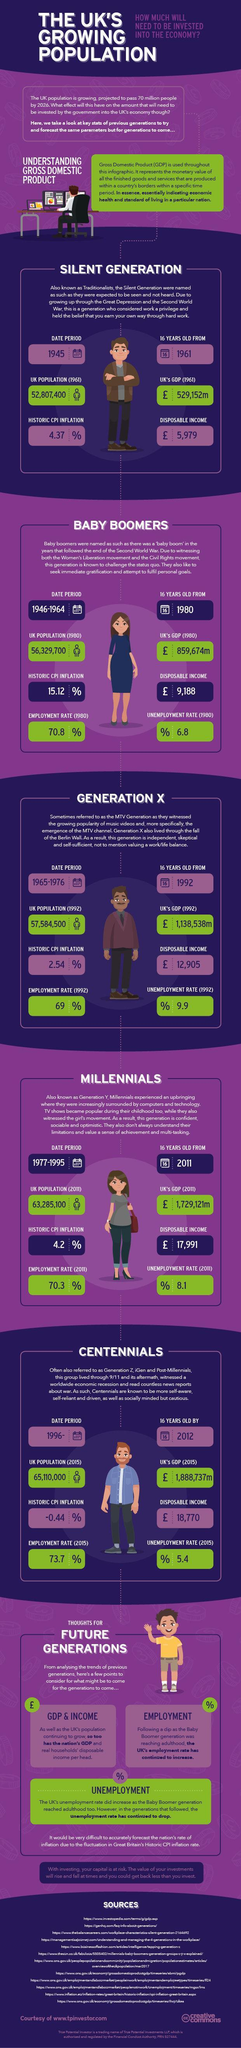What was the population of UK in 1980
Answer the question with a short phrase. 56,329,700 What were the main events during the growing up of the baby boomers Women's Liberation movement and the Civil Rights movement What are the 3 main points to be considered for future generations GDP & Income, Employment, Unemployment What was the disposable income in pounds of the silent generation 5,979 From which year did the baby boomers reach 16 years 1980 What is the difference in disposable income in pounds between the silent generation and the generation x 6926 What is the disposable income of Generation X in pounds 12,905 What is written inside the calender beside 1961 16 What were the main events during the growing up of the silent generation Great Depression and the Second World War 